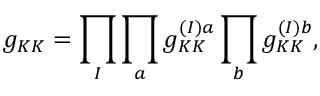Convert formula to latex. <formula><loc_0><loc_0><loc_500><loc_500>g _ { K K } = \prod _ { I } \prod _ { a } g _ { K K } ^ { ( I ) a } \prod _ { b } g _ { K K } ^ { ( I ) b } ,</formula> 